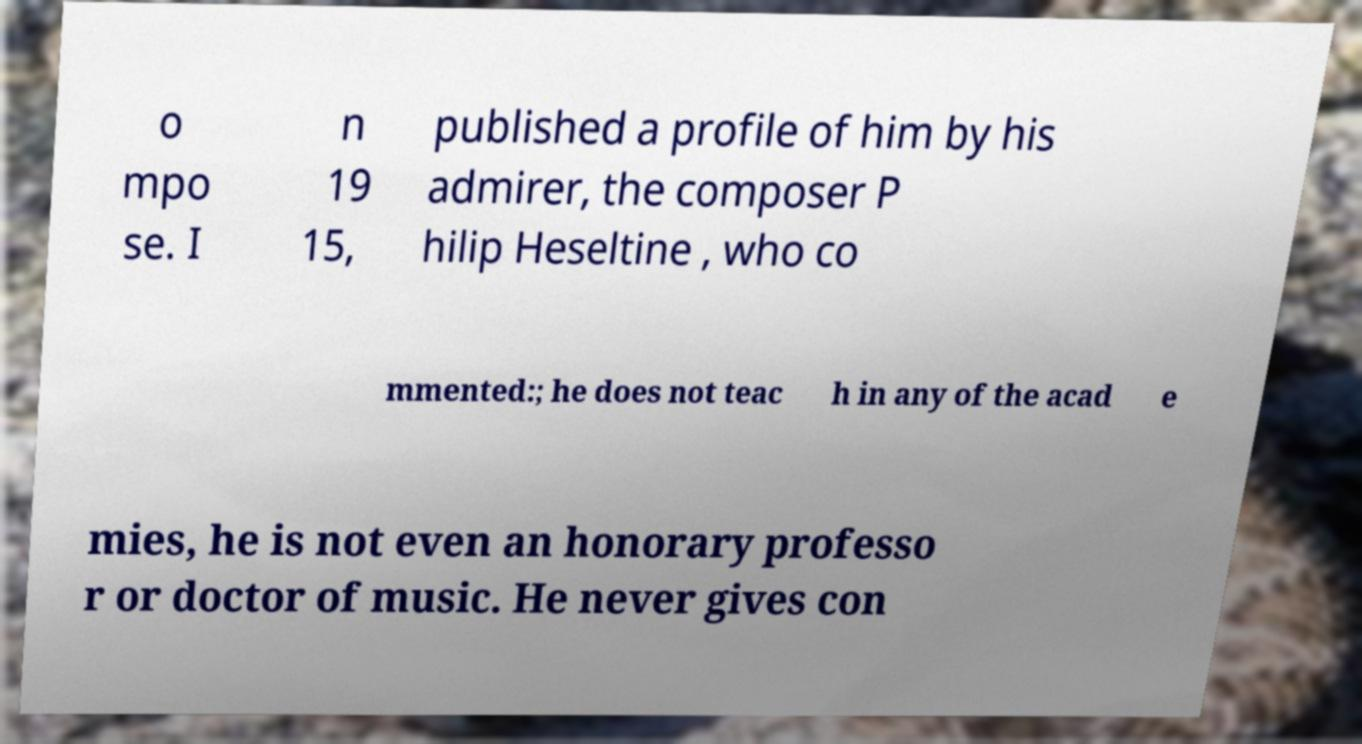Please identify and transcribe the text found in this image. o mpo se. I n 19 15, published a profile of him by his admirer, the composer P hilip Heseltine , who co mmented:; he does not teac h in any of the acad e mies, he is not even an honorary professo r or doctor of music. He never gives con 